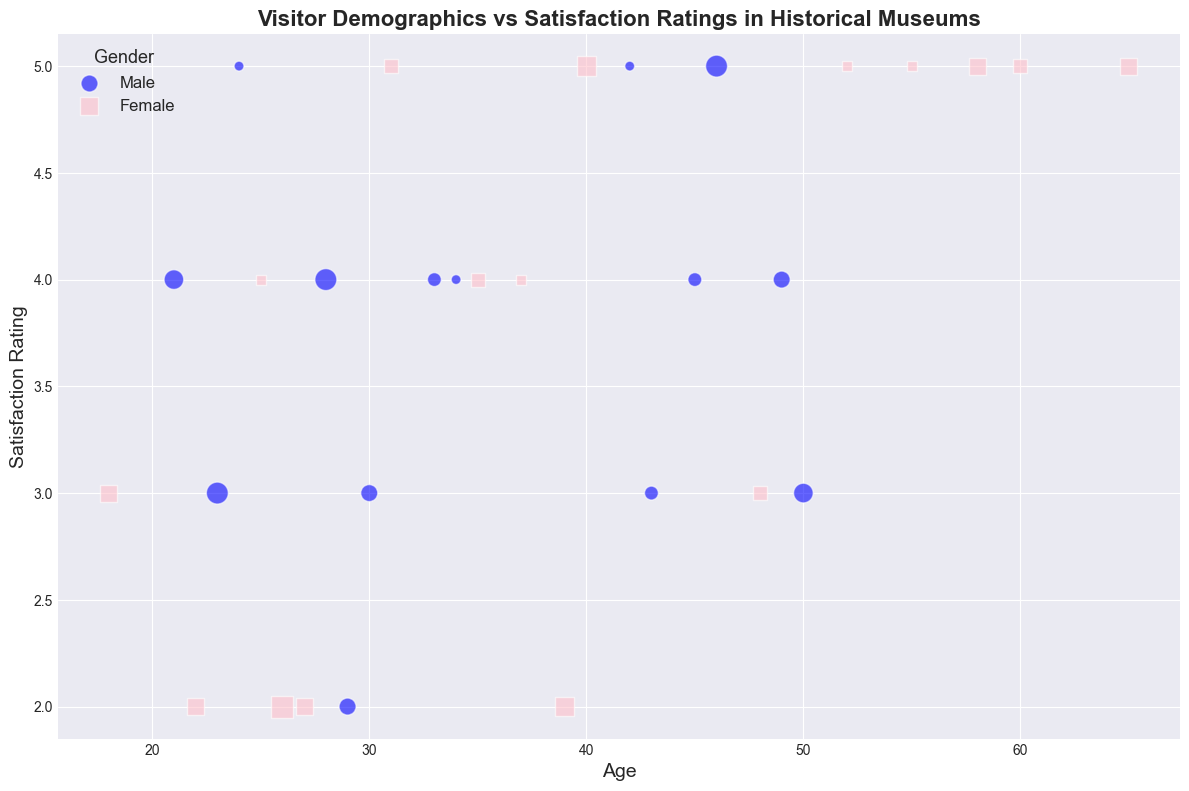At what age do we observe the highest satisfaction rating for male visitors? To find the highest satisfaction rating for male visitors, we look for the blue markers on the scatter plot and identify the highest point on the y-axis. The highest satisfaction rating value for a male visitor (a blue circle) appears at Age 42.
Answer: 42 Which gender shows more variability in their satisfaction ratings? To determine which gender shows more variability, we examine the distribution of pink squares (females) and blue circles (males) along the y-axis. Female visitors (pink squares) have satisfaction ratings ranging from 2 to 5, whereas male visitors (blue circles) range from 2 to 5 as well. However, females have a greater spread across different age groups within these ratings.
Answer: Female Is there a specific visit frequency most common among visitors with the highest satisfaction ratings? To find the most common visit frequency among the highest satisfaction ratings (5), we look for the largest marker size associated with satisfaction rating 5. Observing them, we note frequent appearances of the larger markers (which correspond to visit frequency) appear mostly around 1 and 2.
Answer: 1 and 2 What age group has the most visitors with a satisfaction rating of 4 or above? We need to count the number of markers at or above satisfaction rating 4 and check their corresponding ages. Ages with the highest counts are between 18 and 25 with both gender markers present prominently.
Answer: 18-25 Which education level appears to have the highest concentration of visitors with a satisfaction rating of 5? Although education level is not visually indicated, visitors with different satisfaction levels can be distributed. Observing markers for those rating 5 and checking their ages: Age groups like 24, 55, 60, 52 may predominantly have users with advanced education like Doctorate.
Answer: Doctorate Among visitors who visit the museum 3 times, which gender has the lowest satisfaction rating? To find the gender with the lowest satisfaction rating among those who visit 3 times, look for markers with medium size (representing visit frequency 3) and identify the lowest point on the y-axis. A medium-sized pink square indicates that females have the lowest satisfaction rating at this visit frequency with a rating of 2.
Answer: Female Do younger visitors (under 30) generally have higher satisfaction ratings compared to older visitors (over 50)? To compare satisfaction ratings between age groups, locate markers for visitors under 30 and those over 50 and compare their y-axis positions. Younger visitors (under 30) have a wider range of satisfaction ratings (2 to 5) while older visitors (over 50) generally have high satisfaction ratings concentrated at 4 and 5.
Answer: Older visitors How does the satisfaction rating trend with increasing visit frequency for female visitors? For female visitors (pink squares), examine the size of the pink squares as we move upward on the y-axis. The pattern indicates that as the visit frequency (indicated by larger marker size) increases, satisfaction rating seems to have diverse values, but majority with higher ratings (4-and-above ratings).
Answer: Mixed, with high ratings present 